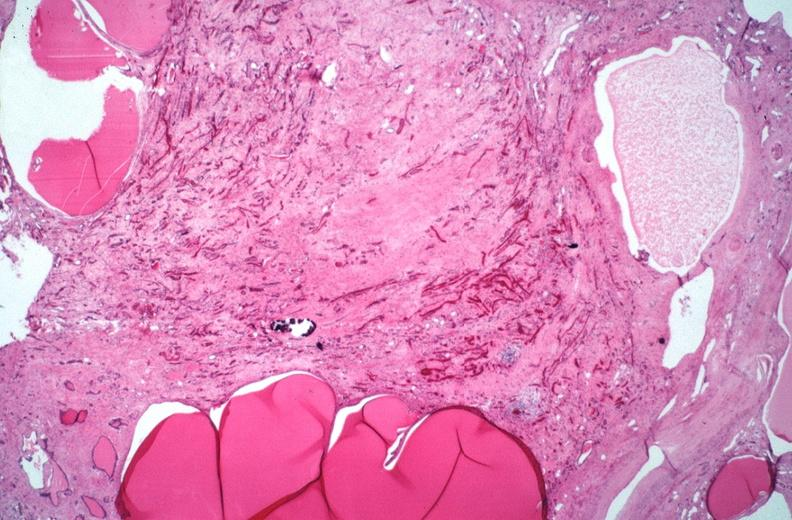where is this?
Answer the question using a single word or phrase. Urinary 